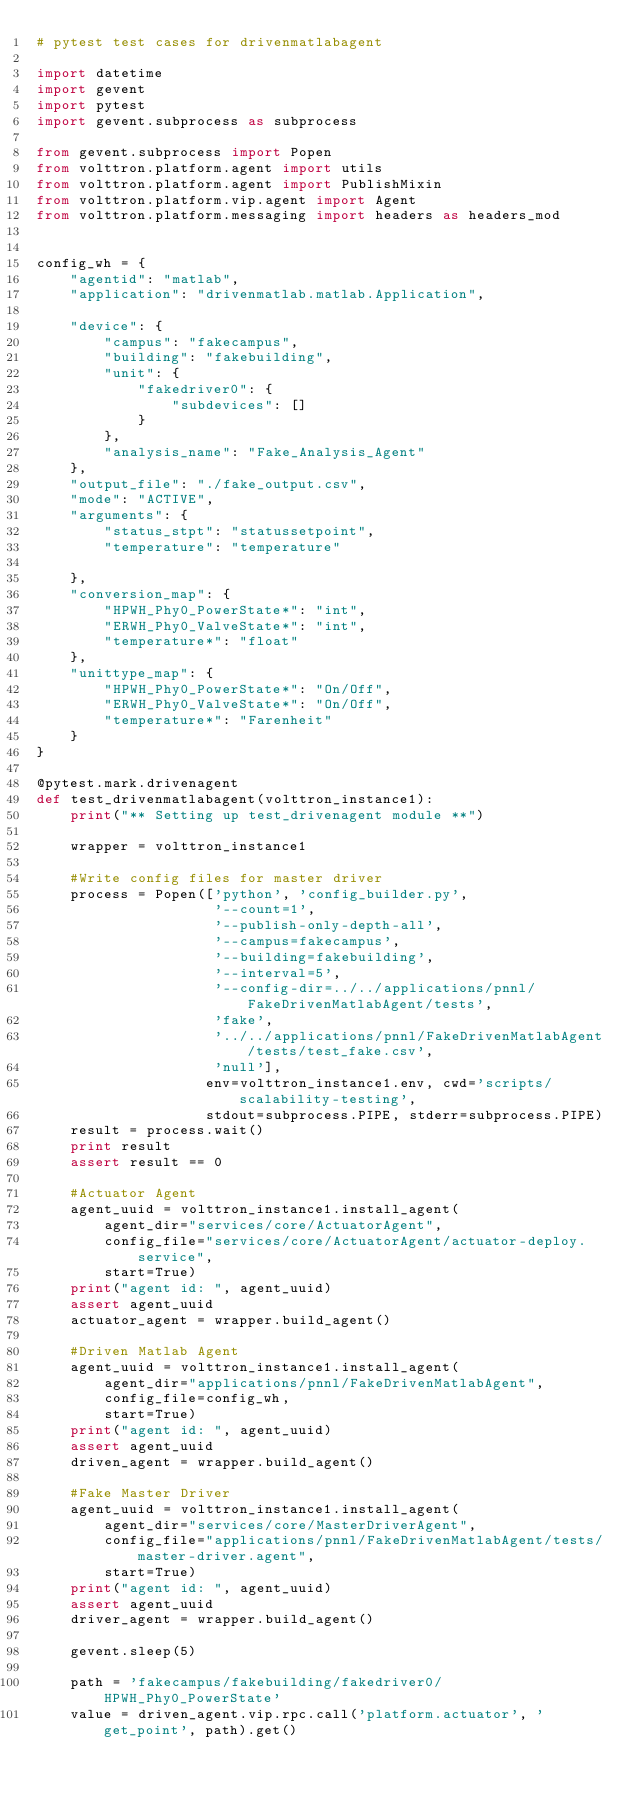Convert code to text. <code><loc_0><loc_0><loc_500><loc_500><_Python_># pytest test cases for drivenmatlabagent

import datetime
import gevent
import pytest
import gevent.subprocess as subprocess

from gevent.subprocess import Popen
from volttron.platform.agent import utils
from volttron.platform.agent import PublishMixin
from volttron.platform.vip.agent import Agent
from volttron.platform.messaging import headers as headers_mod


config_wh = {
    "agentid": "matlab",
    "application": "drivenmatlab.matlab.Application",

    "device": {
        "campus": "fakecampus",
        "building": "fakebuilding",
        "unit": {
            "fakedriver0": {
                "subdevices": []
            }
        },
        "analysis_name": "Fake_Analysis_Agent"
    },
    "output_file": "./fake_output.csv",
    "mode": "ACTIVE",
    "arguments": {
        "status_stpt": "statussetpoint",
        "temperature": "temperature"
        
    },
    "conversion_map": {
        "HPWH_Phy0_PowerState*": "int",
        "ERWH_Phy0_ValveState*": "int",
        "temperature*": "float"
    },
    "unittype_map": {
        "HPWH_Phy0_PowerState*": "On/Off",
        "ERWH_Phy0_ValveState*": "On/Off",
        "temperature*": "Farenheit"
    }
}

@pytest.mark.drivenagent
def test_drivenmatlabagent(volttron_instance1):
    print("** Setting up test_drivenagent module **")
    
    wrapper = volttron_instance1
    
    #Write config files for master driver
    process = Popen(['python', 'config_builder.py', 
                     '--count=1', 
                     '--publish-only-depth-all',
                     '--campus=fakecampus',
                     '--building=fakebuilding',
                     '--interval=5',
                     '--config-dir=../../applications/pnnl/FakeDrivenMatlabAgent/tests',
                     'fake', 
                     '../../applications/pnnl/FakeDrivenMatlabAgent/tests/test_fake.csv', 
                     'null'], 
                    env=volttron_instance1.env, cwd='scripts/scalability-testing',
                    stdout=subprocess.PIPE, stderr=subprocess.PIPE)
    result = process.wait()
    print result
    assert result == 0
     
    #Actuator Agent
    agent_uuid = volttron_instance1.install_agent(
        agent_dir="services/core/ActuatorAgent",
        config_file="services/core/ActuatorAgent/actuator-deploy.service",
        start=True)
    print("agent id: ", agent_uuid)
    assert agent_uuid
    actuator_agent = wrapper.build_agent()
     
    #Driven Matlab Agent
    agent_uuid = volttron_instance1.install_agent(
        agent_dir="applications/pnnl/FakeDrivenMatlabAgent",
        config_file=config_wh,
        start=True)
    print("agent id: ", agent_uuid)
    assert agent_uuid
    driven_agent = wrapper.build_agent()
     
    #Fake Master Driver
    agent_uuid = volttron_instance1.install_agent(
        agent_dir="services/core/MasterDriverAgent",
        config_file="applications/pnnl/FakeDrivenMatlabAgent/tests/master-driver.agent",
        start=True)
    print("agent id: ", agent_uuid)
    assert agent_uuid
    driver_agent = wrapper.build_agent()
     
    gevent.sleep(5)
     
    path = 'fakecampus/fakebuilding/fakedriver0/HPWH_Phy0_PowerState'
    value = driven_agent.vip.rpc.call('platform.actuator', 'get_point', path).get()</code> 